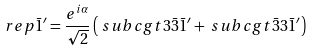Convert formula to latex. <formula><loc_0><loc_0><loc_500><loc_500>\ r e p { \bar { 1 } ^ { \prime } } & = \frac { e ^ { i \alpha } } { \sqrt { 2 } } \left ( \ s u b c g t { 3 } { \bar { 3 } } { \bar { 1 } ^ { \prime } } + \ s u b c g t { \bar { 3 } } { 3 } { \bar { 1 } ^ { \prime } } \right )</formula> 